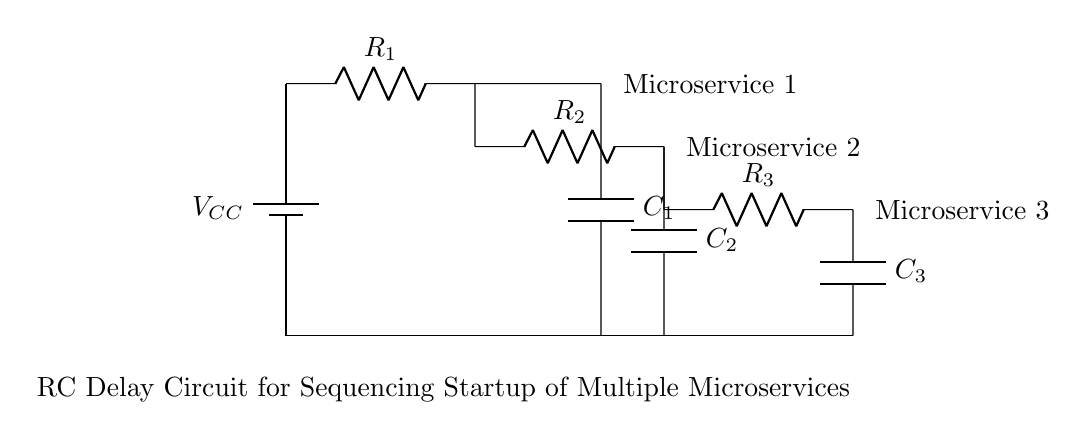What is the voltage source in this circuit? The voltage source is positioned at the top of the circuit, labeled as VCC, which typically represents the positive supply voltage.
Answer: VCC What is the value of the first resistor? The first resistor, labeled as R1, is connected directly across the voltage source and is the first element in the circuit, indicating its position relative to the source.
Answer: R1 How many capacitors are present in this circuit? There are three capacitors labeled as C1, C2, and C3, with each connected in parallel to their respective resistor branches, contributing to the total delay effect.
Answer: Three What defines the sequencing of the microservices in this RC delay circuit? The sequencing is defined by the time constant (τ) derived from each resistor-capacitor combination, which dictates how quickly each microservice receives power after the previous one has powered up.
Answer: Time constant What does the resistor-capacitor combination do in this circuit? The resistor-capacitor combination creates a delay in voltage rise, allowing each microservice to start sequentially rather than simultaneously, reducing load on the power supply.
Answer: Creates a delay What is the role of R2 in the circuit? R2 connects in parallel with C2 and determines the discharge rate of the capacitor, affecting the timing for the second microservice to start as R2 and C2 form their own time constant.
Answer: Determines timing How would an increase in capacitance (C) affect the delay for microservice startup? Increasing the capacitance would increase the time constant (τ = R*C), which would prolong the delay for each microservice initiation based on the RC time delay formula.
Answer: Prolongs delay 